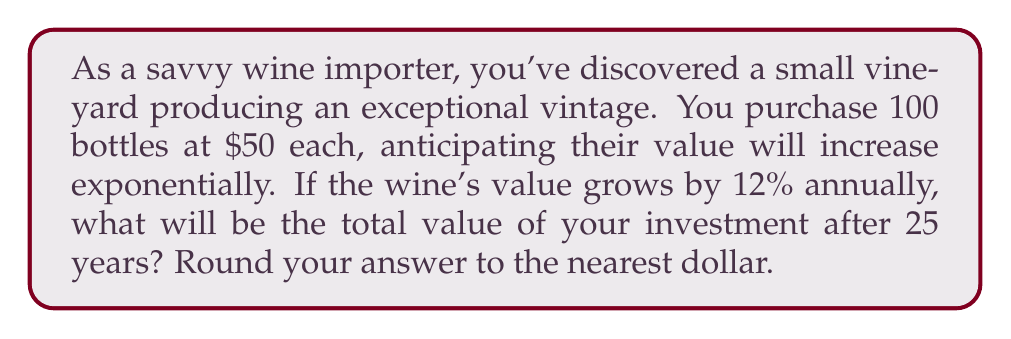What is the answer to this math problem? Let's approach this step-by-step:

1) First, we need to calculate the growth factor. With a 12% annual increase, the growth factor is:
   $1 + 0.12 = 1.12$

2) The initial investment is:
   $100 \text{ bottles} \times \$50 \text{ per bottle} = \$5000$

3) To calculate the value after 25 years, we use the compound interest formula:
   $A = P(1 + r)^t$
   Where:
   $A$ is the final amount
   $P$ is the principal (initial investment)
   $r$ is the annual growth rate
   $t$ is the time in years

4) Plugging in our values:
   $A = 5000(1.12)^{25}$

5) Now we calculate:
   $A = 5000 \times 17.0000995$
   $A = 85000.4975$

6) Rounding to the nearest dollar:
   $A \approx \$85,000$
Answer: $85,000 